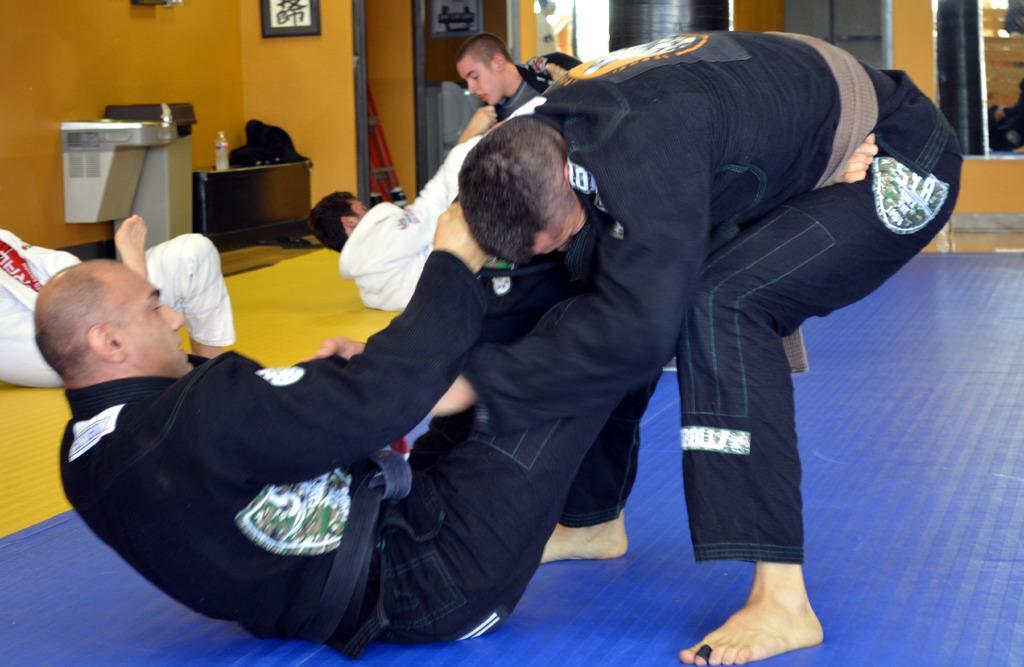Could you give a brief overview of what you see in this image? In this picture we can see there are groups of people on the floor and the people are performing the stunts. Behind the people there is an orange wall with a photo frame and other things. 